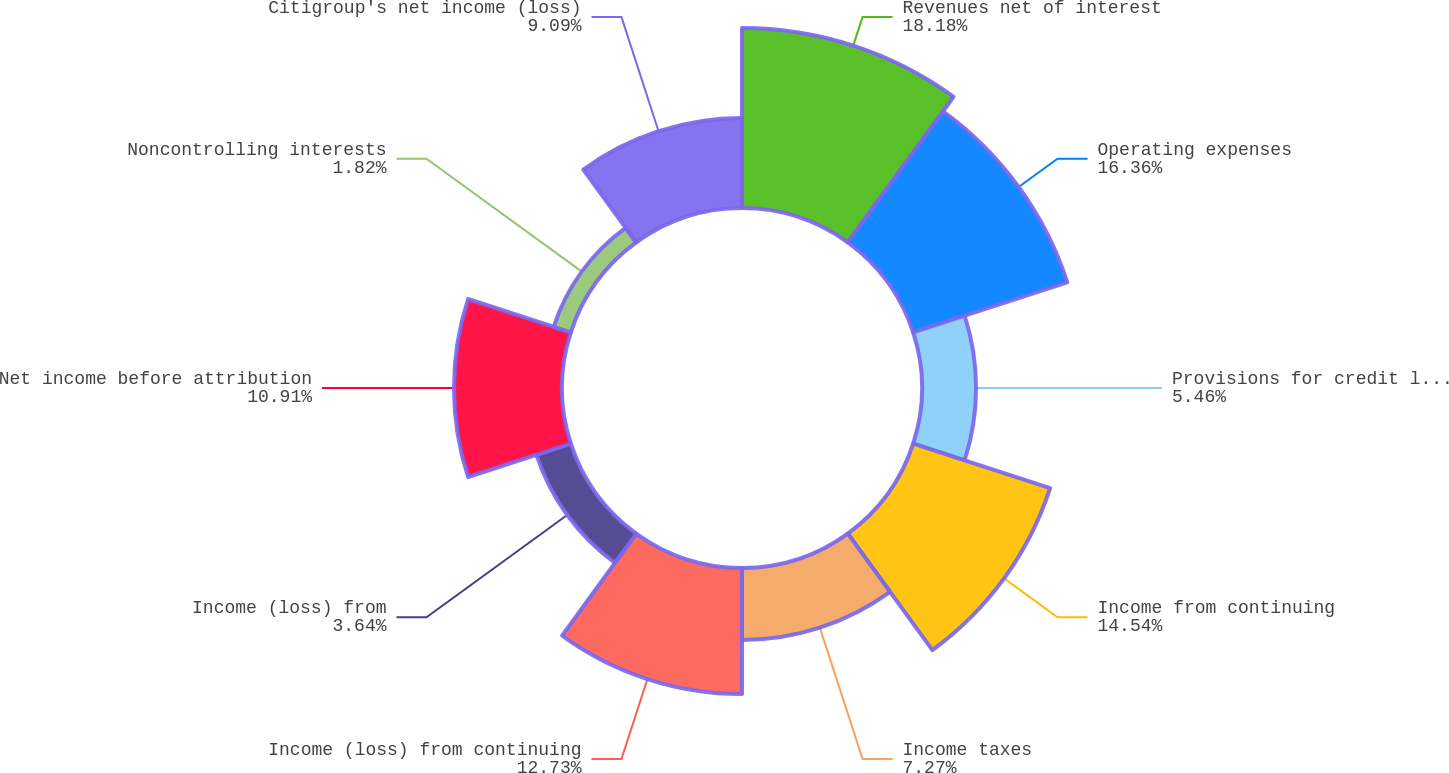Convert chart to OTSL. <chart><loc_0><loc_0><loc_500><loc_500><pie_chart><fcel>Revenues net of interest<fcel>Operating expenses<fcel>Provisions for credit losses<fcel>Income from continuing<fcel>Income taxes<fcel>Income (loss) from continuing<fcel>Income (loss) from<fcel>Net income before attribution<fcel>Noncontrolling interests<fcel>Citigroup's net income (loss)<nl><fcel>18.18%<fcel>16.36%<fcel>5.46%<fcel>14.54%<fcel>7.27%<fcel>12.73%<fcel>3.64%<fcel>10.91%<fcel>1.82%<fcel>9.09%<nl></chart> 